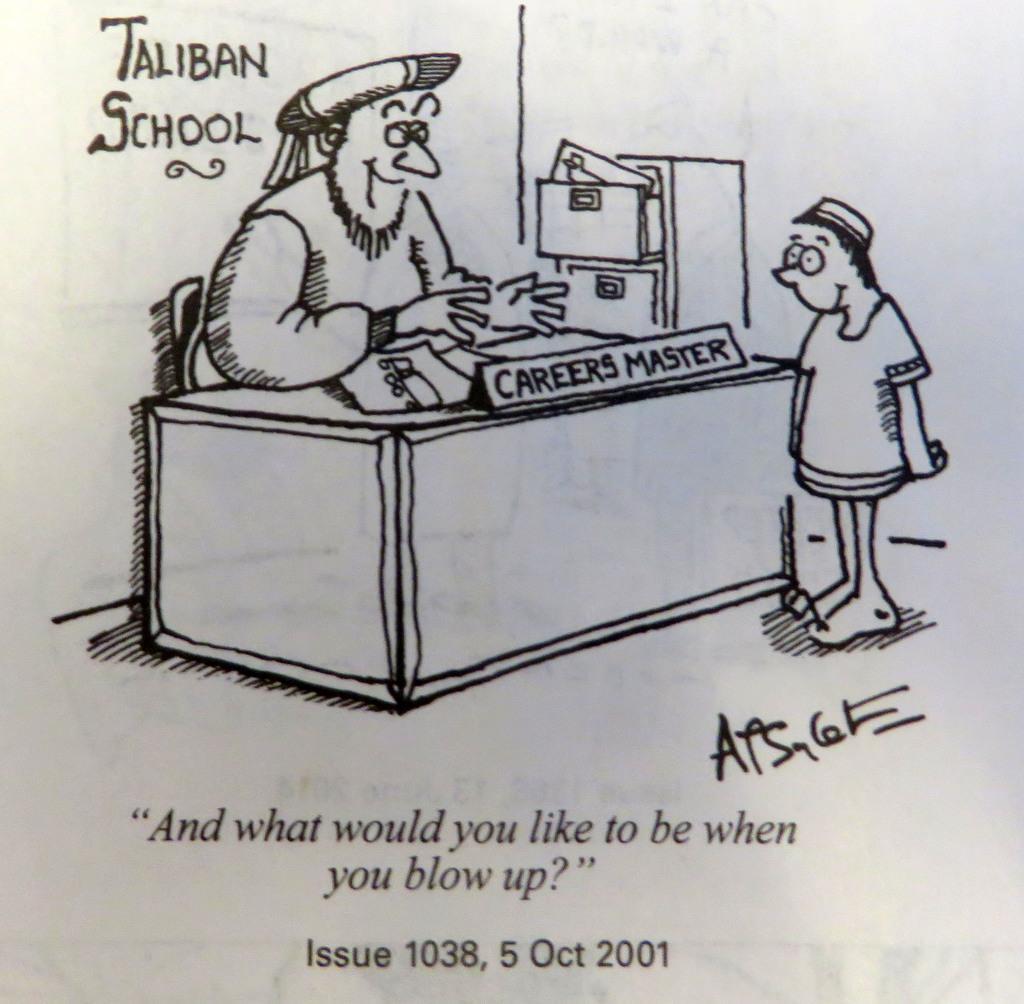Describe this image in one or two sentences. This is a poster and in this poster we can see a man sitting on a chair and a table with papers, name board on it, person standing, drawers and some text. 